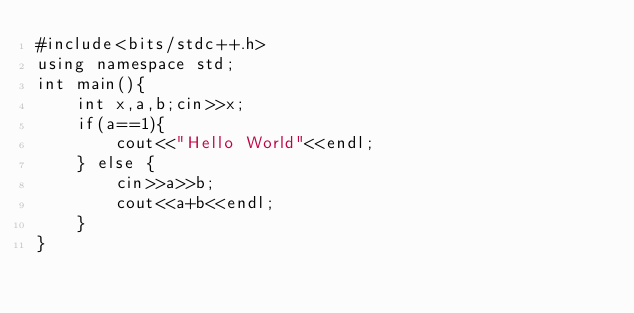Convert code to text. <code><loc_0><loc_0><loc_500><loc_500><_C++_>#include<bits/stdc++.h>
using namespace std;
int main(){
    int x,a,b;cin>>x;
    if(a==1){
        cout<<"Hello World"<<endl;
    } else {
        cin>>a>>b;
        cout<<a+b<<endl;
    }
}</code> 